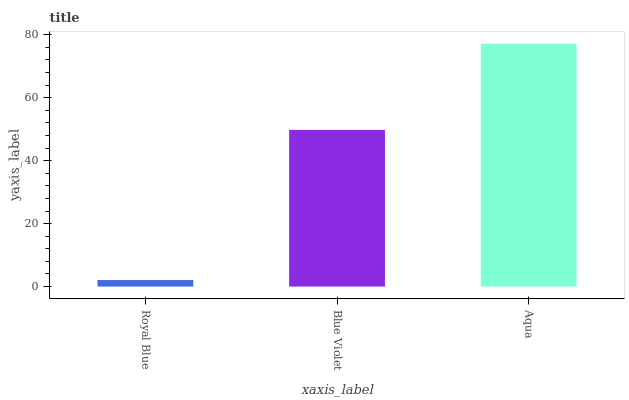Is Royal Blue the minimum?
Answer yes or no. Yes. Is Aqua the maximum?
Answer yes or no. Yes. Is Blue Violet the minimum?
Answer yes or no. No. Is Blue Violet the maximum?
Answer yes or no. No. Is Blue Violet greater than Royal Blue?
Answer yes or no. Yes. Is Royal Blue less than Blue Violet?
Answer yes or no. Yes. Is Royal Blue greater than Blue Violet?
Answer yes or no. No. Is Blue Violet less than Royal Blue?
Answer yes or no. No. Is Blue Violet the high median?
Answer yes or no. Yes. Is Blue Violet the low median?
Answer yes or no. Yes. Is Royal Blue the high median?
Answer yes or no. No. Is Royal Blue the low median?
Answer yes or no. No. 